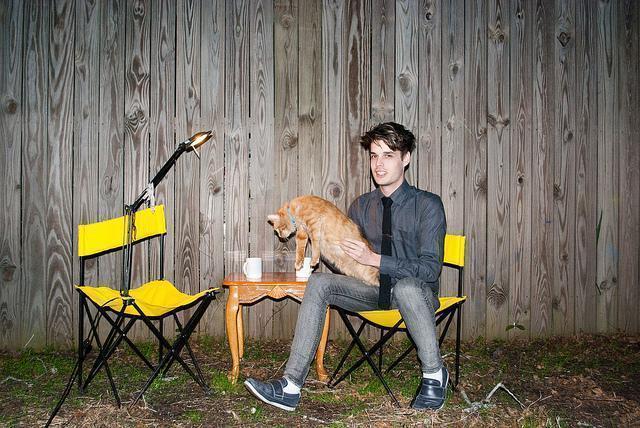What is the breed of this cat?
Choose the correct response and explain in the format: 'Answer: answer
Rationale: rationale.'
Options: Ragdoll, persian, maine coon, scottish fold. Answer: ragdoll.
Rationale: This is an orange cat. 